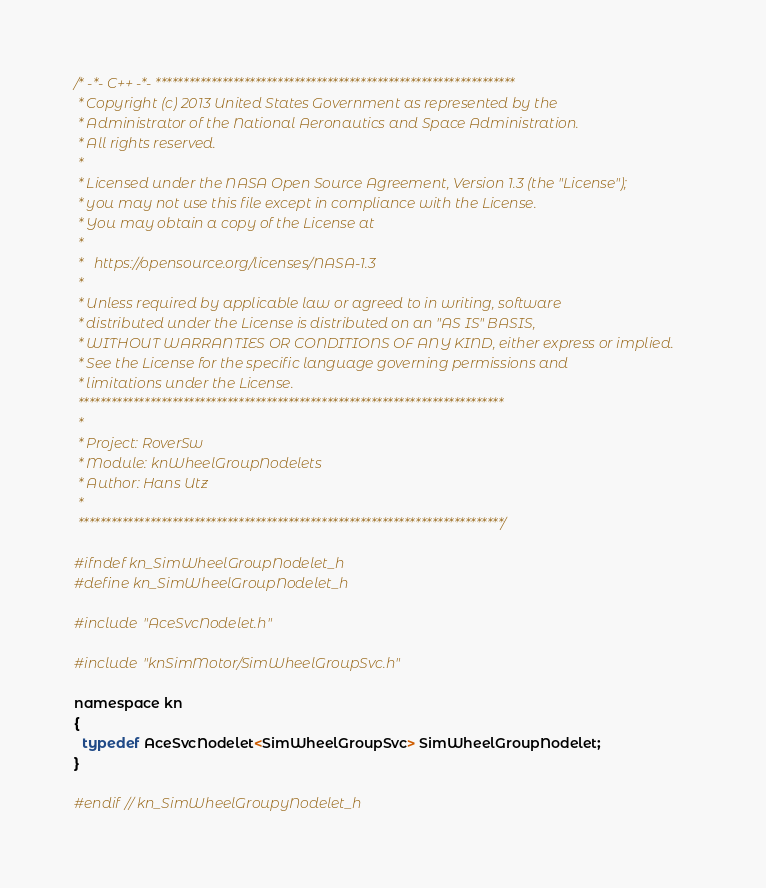Convert code to text. <code><loc_0><loc_0><loc_500><loc_500><_C_>/* -*- C++ -*- *****************************************************************
 * Copyright (c) 2013 United States Government as represented by the
 * Administrator of the National Aeronautics and Space Administration.
 * All rights reserved.
 *
 * Licensed under the NASA Open Source Agreement, Version 1.3 (the "License");
 * you may not use this file except in compliance with the License.
 * You may obtain a copy of the License at
 *
 *   https://opensource.org/licenses/NASA-1.3
 *
 * Unless required by applicable law or agreed to in writing, software
 * distributed under the License is distributed on an "AS IS" BASIS,
 * WITHOUT WARRANTIES OR CONDITIONS OF ANY KIND, either express or implied.
 * See the License for the specific language governing permissions and
 * limitations under the License.
 *****************************************************************************
 *
 * Project: RoverSw
 * Module: knWheelGroupNodelets
 * Author: Hans Utz
 *
 *****************************************************************************/

#ifndef kn_SimWheelGroupNodelet_h
#define kn_SimWheelGroupNodelet_h

#include "AceSvcNodelet.h"

#include "knSimMotor/SimWheelGroupSvc.h"

namespace kn
{
  typedef AceSvcNodelet<SimWheelGroupSvc> SimWheelGroupNodelet;
}

#endif // kn_SimWheelGroupyNodelet_h
</code> 